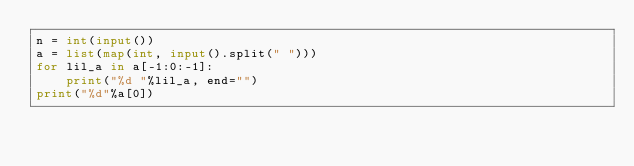<code> <loc_0><loc_0><loc_500><loc_500><_Python_>n = int(input())
a = list(map(int, input().split(" ")))
for lil_a in a[-1:0:-1]:
    print("%d "%lil_a, end="")
print("%d"%a[0])</code> 